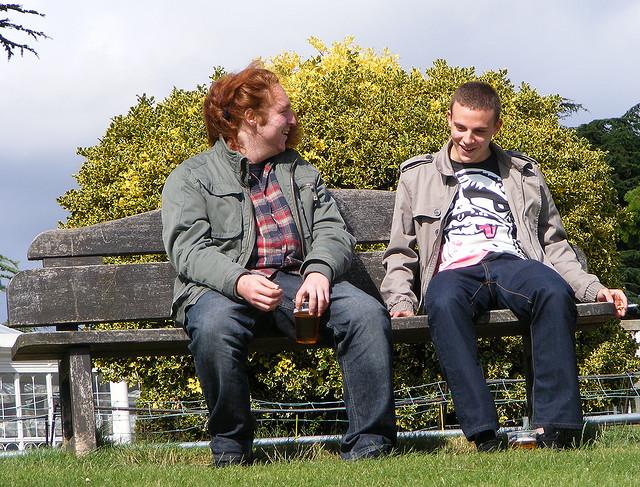Is the bench made of metal?
Give a very brief answer. No. Is the man on the right happy?
Write a very short answer. Yes. What color is the man's hair on the left?
Short answer required. Red. 